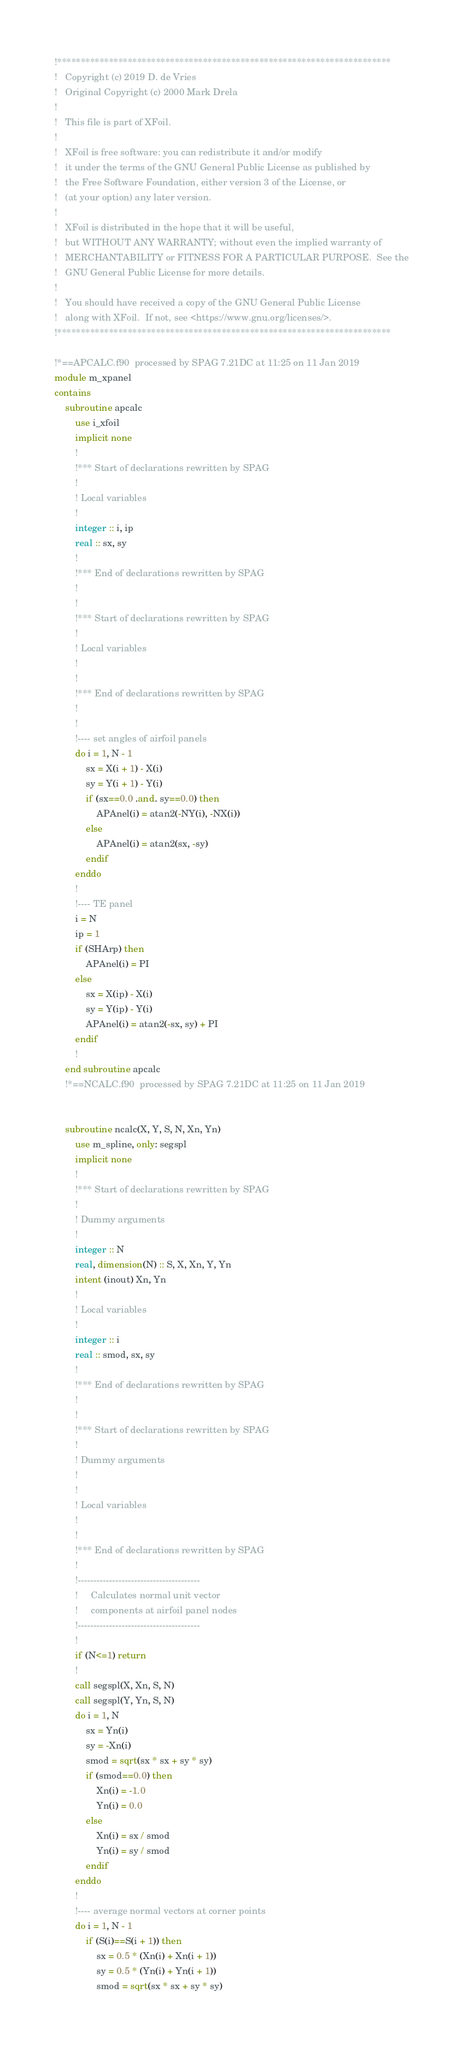Convert code to text. <code><loc_0><loc_0><loc_500><loc_500><_FORTRAN_>!***********************************************************************
!   Copyright (c) 2019 D. de Vries
!   Original Copyright (c) 2000 Mark Drela
!
!   This file is part of XFoil.
!
!   XFoil is free software: you can redistribute it and/or modify
!   it under the terms of the GNU General Public License as published by
!   the Free Software Foundation, either version 3 of the License, or
!   (at your option) any later version.
!
!   XFoil is distributed in the hope that it will be useful,
!   but WITHOUT ANY WARRANTY; without even the implied warranty of
!   MERCHANTABILITY or FITNESS FOR A PARTICULAR PURPOSE.  See the
!   GNU General Public License for more details.
!
!   You should have received a copy of the GNU General Public License
!   along with XFoil.  If not, see <https://www.gnu.org/licenses/>.
!***********************************************************************

!*==APCALC.f90  processed by SPAG 7.21DC at 11:25 on 11 Jan 2019
module m_xpanel
contains
    subroutine apcalc
        use i_xfoil
        implicit none
        !
        !*** Start of declarations rewritten by SPAG
        !
        ! Local variables
        !
        integer :: i, ip
        real :: sx, sy
        !
        !*** End of declarations rewritten by SPAG
        !
        !
        !*** Start of declarations rewritten by SPAG
        !
        ! Local variables
        !
        !
        !*** End of declarations rewritten by SPAG
        !
        !
        !---- set angles of airfoil panels
        do i = 1, N - 1
            sx = X(i + 1) - X(i)
            sy = Y(i + 1) - Y(i)
            if (sx==0.0 .and. sy==0.0) then
                APAnel(i) = atan2(-NY(i), -NX(i))
            else
                APAnel(i) = atan2(sx, -sy)
            endif
        enddo
        !
        !---- TE panel
        i = N
        ip = 1
        if (SHArp) then
            APAnel(i) = PI
        else
            sx = X(ip) - X(i)
            sy = Y(ip) - Y(i)
            APAnel(i) = atan2(-sx, sy) + PI
        endif
        !
    end subroutine apcalc
    !*==NCALC.f90  processed by SPAG 7.21DC at 11:25 on 11 Jan 2019


    subroutine ncalc(X, Y, S, N, Xn, Yn)
        use m_spline, only: segspl
        implicit none
        !
        !*** Start of declarations rewritten by SPAG
        !
        ! Dummy arguments
        !
        integer :: N
        real, dimension(N) :: S, X, Xn, Y, Yn
        intent (inout) Xn, Yn
        !
        ! Local variables
        !
        integer :: i
        real :: smod, sx, sy
        !
        !*** End of declarations rewritten by SPAG
        !
        !
        !*** Start of declarations rewritten by SPAG
        !
        ! Dummy arguments
        !
        !
        ! Local variables
        !
        !
        !*** End of declarations rewritten by SPAG
        !
        !---------------------------------------
        !     Calculates normal unit vector
        !     components at airfoil panel nodes
        !---------------------------------------
        !
        if (N<=1) return
        !
        call segspl(X, Xn, S, N)
        call segspl(Y, Yn, S, N)
        do i = 1, N
            sx = Yn(i)
            sy = -Xn(i)
            smod = sqrt(sx * sx + sy * sy)
            if (smod==0.0) then
                Xn(i) = -1.0
                Yn(i) = 0.0
            else
                Xn(i) = sx / smod
                Yn(i) = sy / smod
            endif
        enddo
        !
        !---- average normal vectors at corner points
        do i = 1, N - 1
            if (S(i)==S(i + 1)) then
                sx = 0.5 * (Xn(i) + Xn(i + 1))
                sy = 0.5 * (Yn(i) + Yn(i + 1))
                smod = sqrt(sx * sx + sy * sy)</code> 